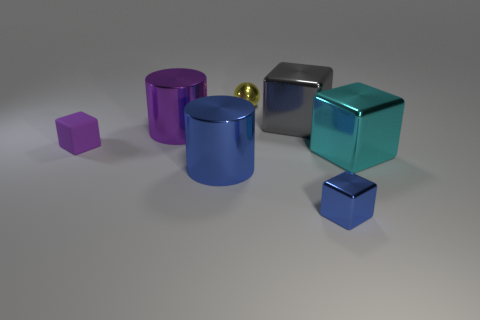Subtract 1 blocks. How many blocks are left? 3 Add 2 small blue rubber blocks. How many objects exist? 9 Subtract all balls. How many objects are left? 6 Add 4 purple rubber objects. How many purple rubber objects exist? 5 Subtract 0 brown blocks. How many objects are left? 7 Subtract all big cylinders. Subtract all large purple metallic objects. How many objects are left? 4 Add 6 large cyan blocks. How many large cyan blocks are left? 7 